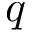<formula> <loc_0><loc_0><loc_500><loc_500>q</formula> 